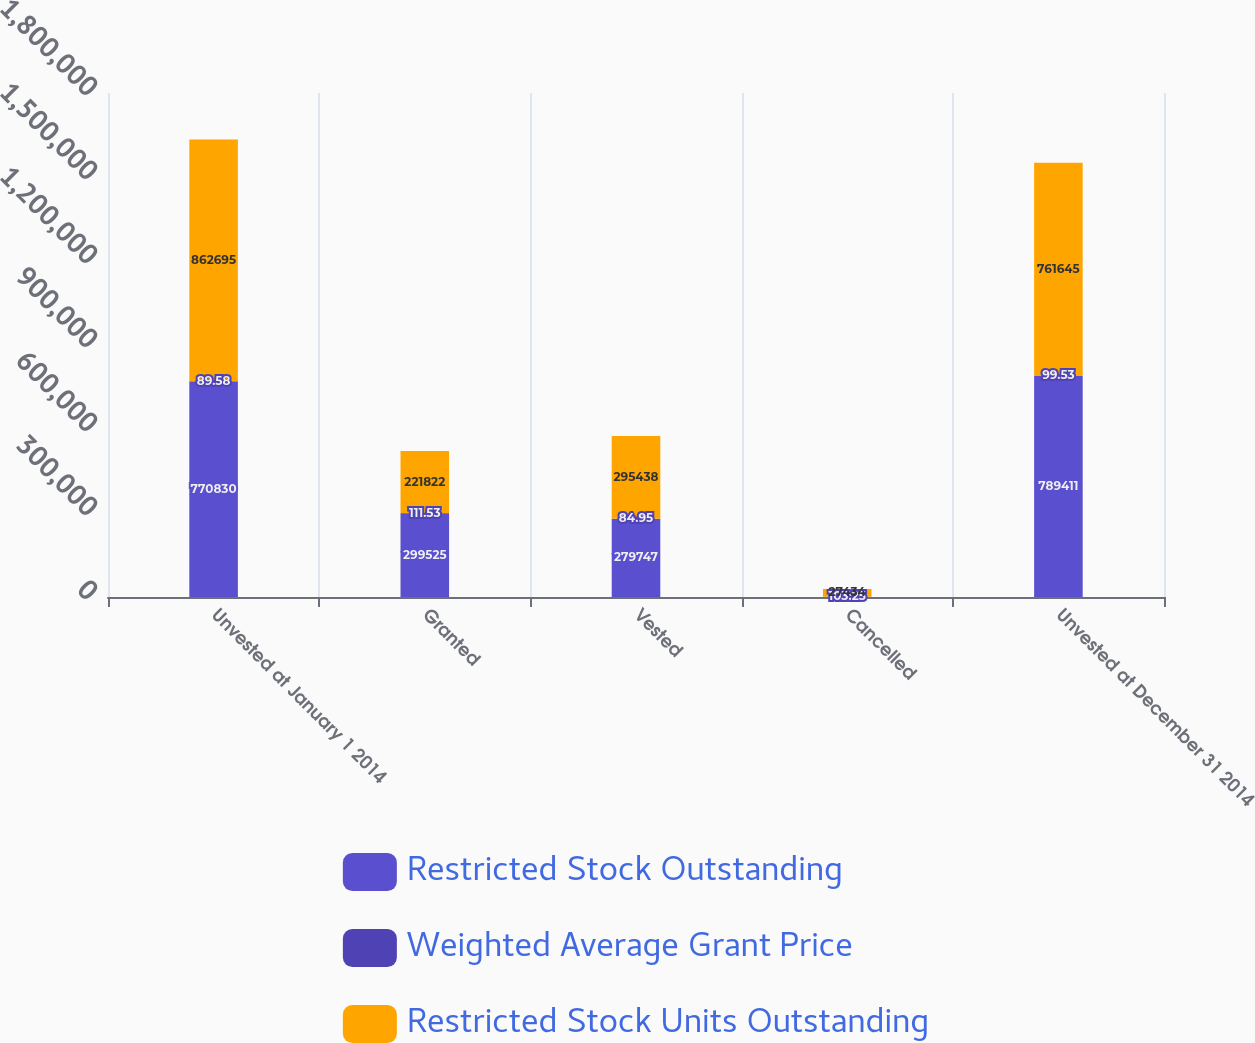<chart> <loc_0><loc_0><loc_500><loc_500><stacked_bar_chart><ecel><fcel>Unvested at January 1 2014<fcel>Granted<fcel>Vested<fcel>Cancelled<fcel>Unvested at December 31 2014<nl><fcel>Restricted Stock Outstanding<fcel>770830<fcel>299525<fcel>279747<fcel>1197<fcel>789411<nl><fcel>Weighted Average Grant Price<fcel>89.58<fcel>111.53<fcel>84.95<fcel>103.25<fcel>99.53<nl><fcel>Restricted Stock Units Outstanding<fcel>862695<fcel>221822<fcel>295438<fcel>27434<fcel>761645<nl></chart> 